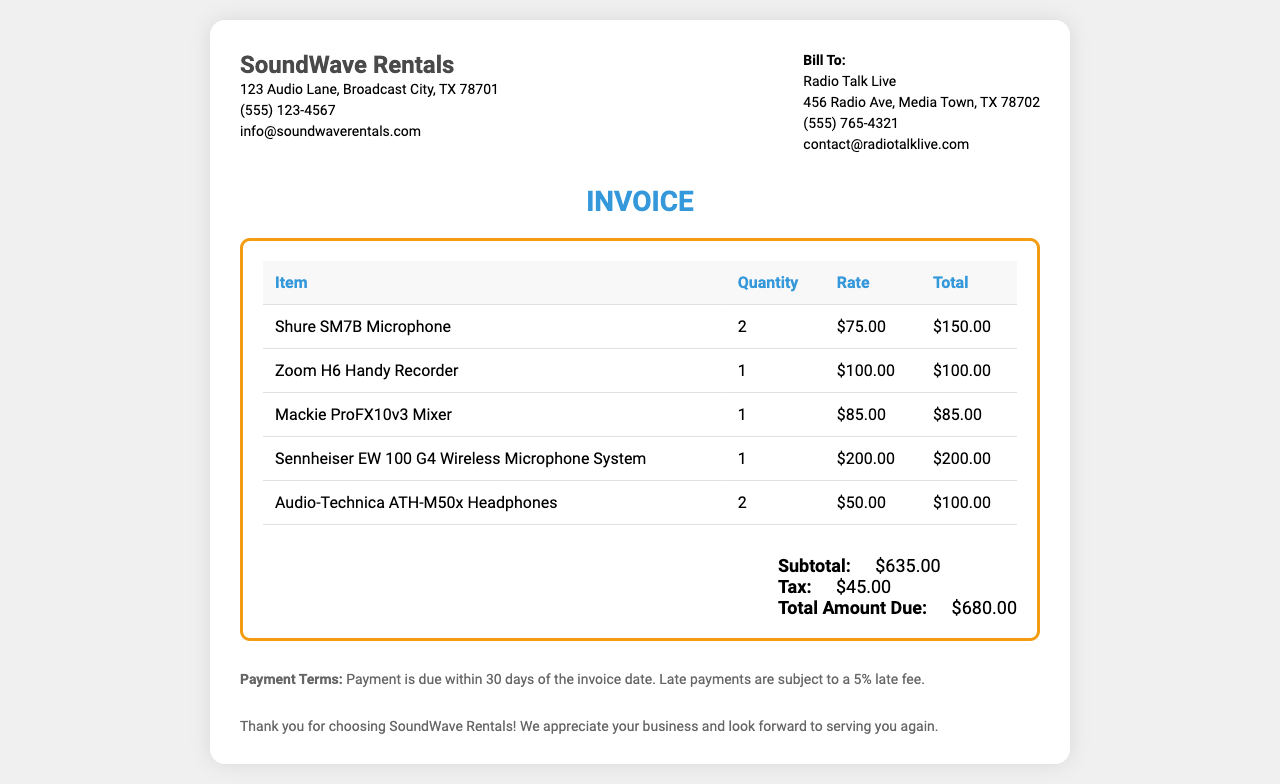What is the total amount due? The total amount due is listed at the bottom of the invoice summing up subtotal and tax.
Answer: $680.00 How many Shure SM7B Microphones were rented? The quantity of Shure SM7B Microphones is specified in the itemized list.
Answer: 2 What is the tax amount charged? The tax amount is shown in the total section of the invoice.
Answer: $45.00 Who is the client for this invoice? The client's information is displayed under the "Bill To" section of the document.
Answer: Radio Talk Live What date should payment be made by? The payment terms indicate that payment is due within 30 days of the invoice date, which is not specified but implies a deadline based on receipt.
Answer: 30 days What item has the highest rental rate? By comparing the rates in the list, the item with the highest rental rate can be identified.
Answer: Sennheiser EW 100 G4 Wireless Microphone System How many Audio-Technica ATH-M50x Headphones were included? The document states the quantity for the Audio-Technica ATH-M50x Headphones in the rental list.
Answer: 2 What is the subtotal of the invoice? The subtotal is provided in the total section before tax is added.
Answer: $635.00 What is the payment term for late payments? The payment terms section states the consequence for late payments.
Answer: 5% late fee 